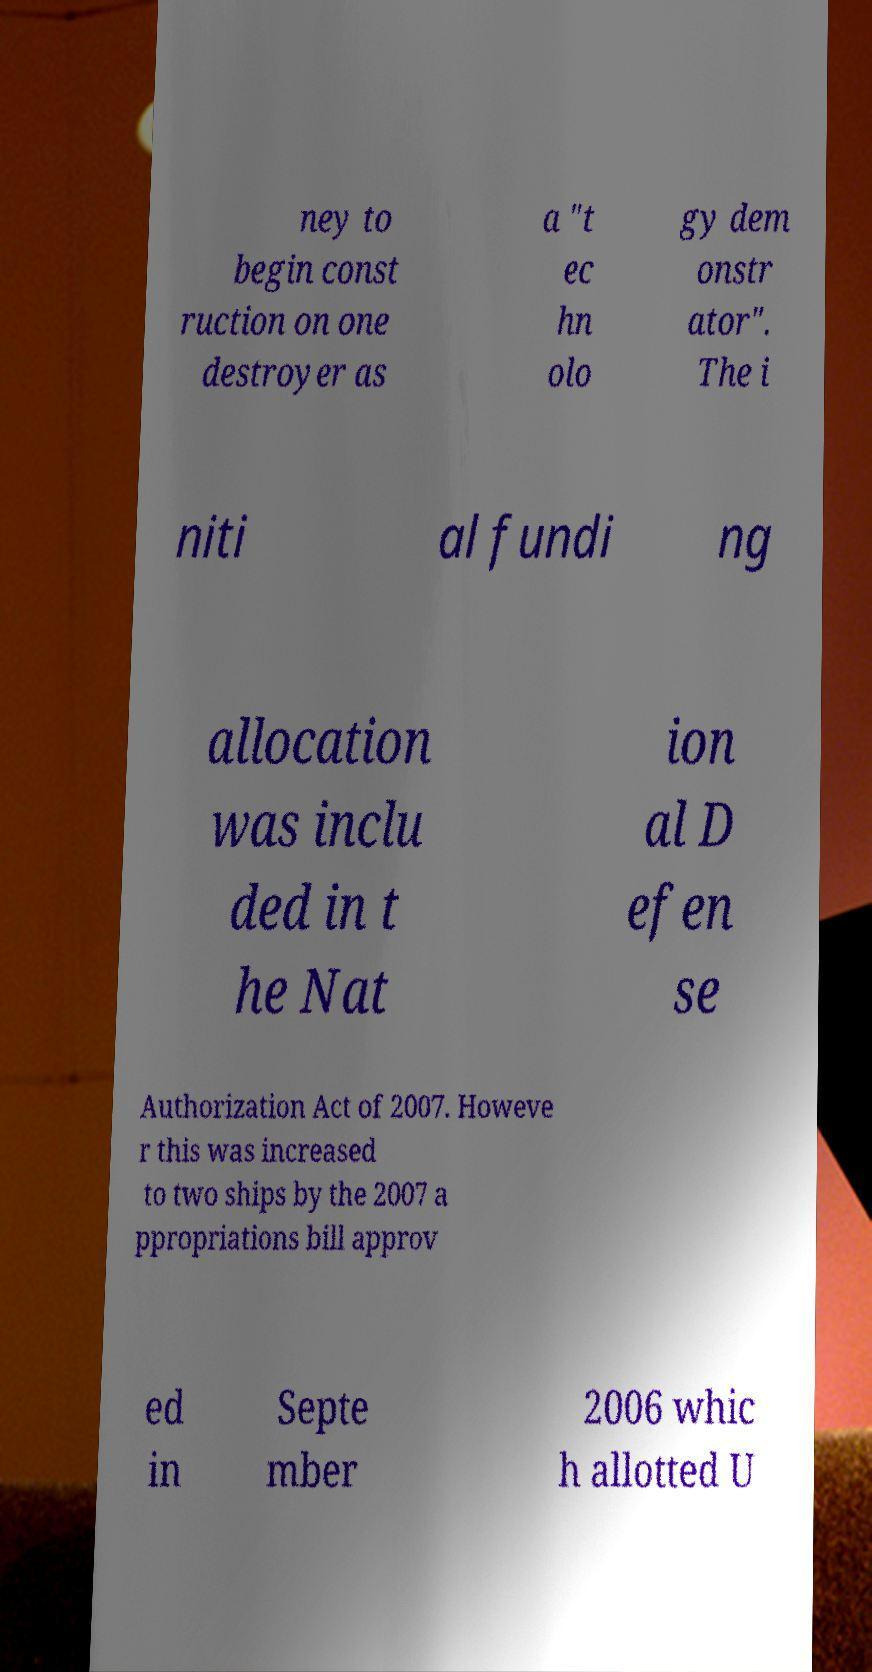I need the written content from this picture converted into text. Can you do that? ney to begin const ruction on one destroyer as a "t ec hn olo gy dem onstr ator". The i niti al fundi ng allocation was inclu ded in t he Nat ion al D efen se Authorization Act of 2007. Howeve r this was increased to two ships by the 2007 a ppropriations bill approv ed in Septe mber 2006 whic h allotted U 